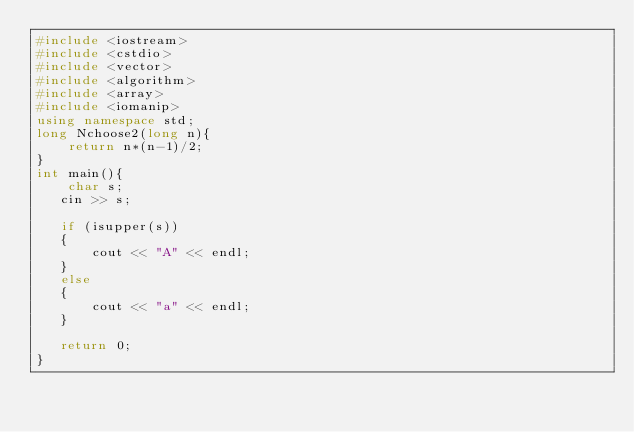Convert code to text. <code><loc_0><loc_0><loc_500><loc_500><_C++_>#include <iostream>
#include <cstdio>
#include <vector>
#include <algorithm>
#include <array>
#include <iomanip>
using namespace std;
long Nchoose2(long n){
    return n*(n-1)/2;
}
int main(){
    char s;
   cin >> s;

   if (isupper(s))
   {
       cout << "A" << endl;
   }
   else
   {
       cout << "a" << endl;
   }

   return 0;
}</code> 